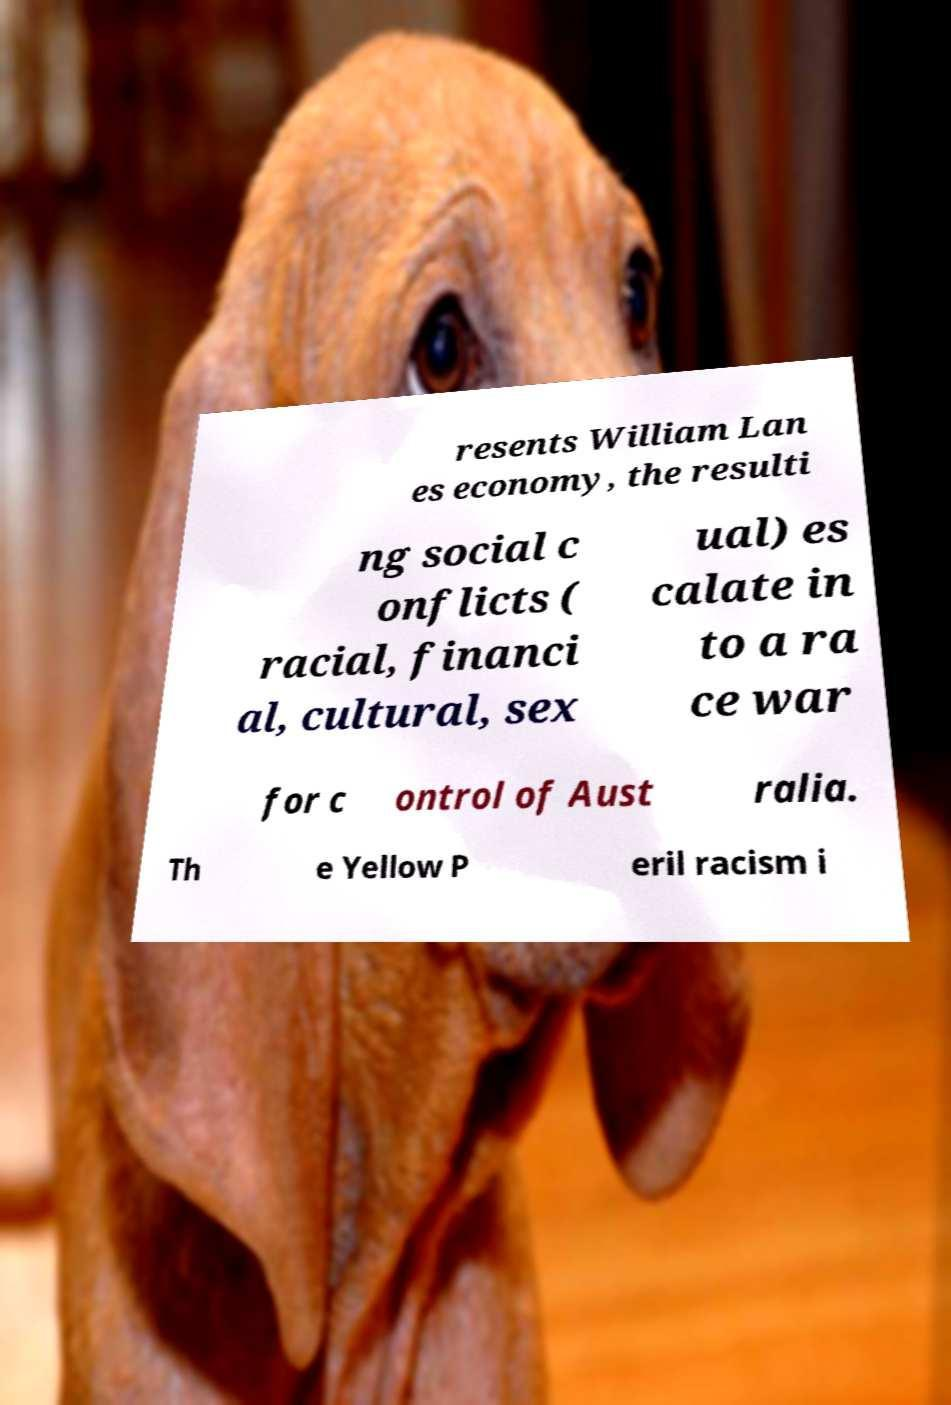Can you accurately transcribe the text from the provided image for me? resents William Lan es economy, the resulti ng social c onflicts ( racial, financi al, cultural, sex ual) es calate in to a ra ce war for c ontrol of Aust ralia. Th e Yellow P eril racism i 